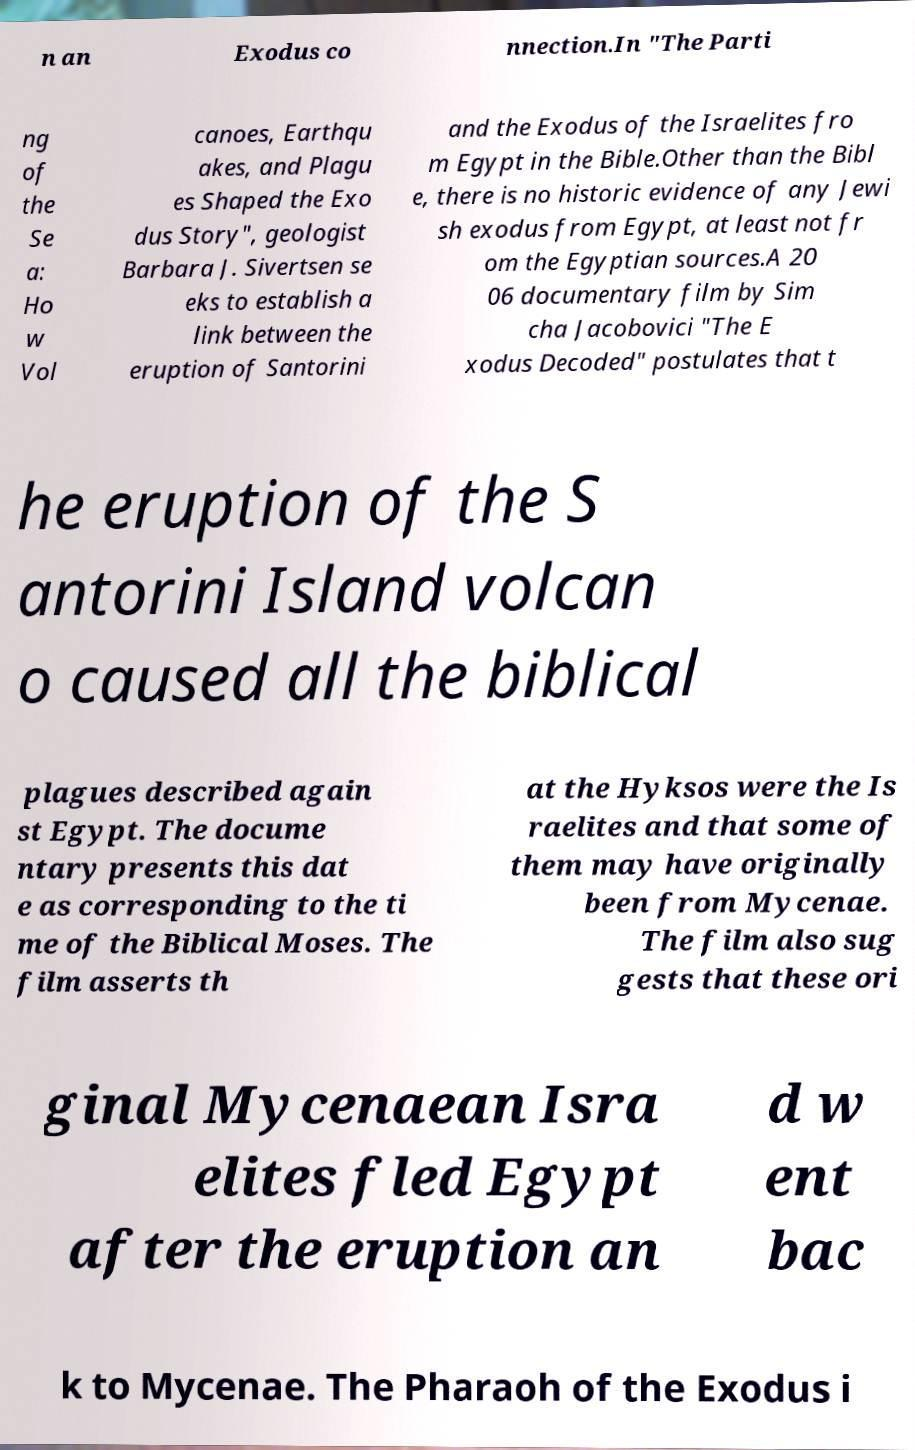Please read and relay the text visible in this image. What does it say? n an Exodus co nnection.In "The Parti ng of the Se a: Ho w Vol canoes, Earthqu akes, and Plagu es Shaped the Exo dus Story", geologist Barbara J. Sivertsen se eks to establish a link between the eruption of Santorini and the Exodus of the Israelites fro m Egypt in the Bible.Other than the Bibl e, there is no historic evidence of any Jewi sh exodus from Egypt, at least not fr om the Egyptian sources.A 20 06 documentary film by Sim cha Jacobovici "The E xodus Decoded" postulates that t he eruption of the S antorini Island volcan o caused all the biblical plagues described again st Egypt. The docume ntary presents this dat e as corresponding to the ti me of the Biblical Moses. The film asserts th at the Hyksos were the Is raelites and that some of them may have originally been from Mycenae. The film also sug gests that these ori ginal Mycenaean Isra elites fled Egypt after the eruption an d w ent bac k to Mycenae. The Pharaoh of the Exodus i 